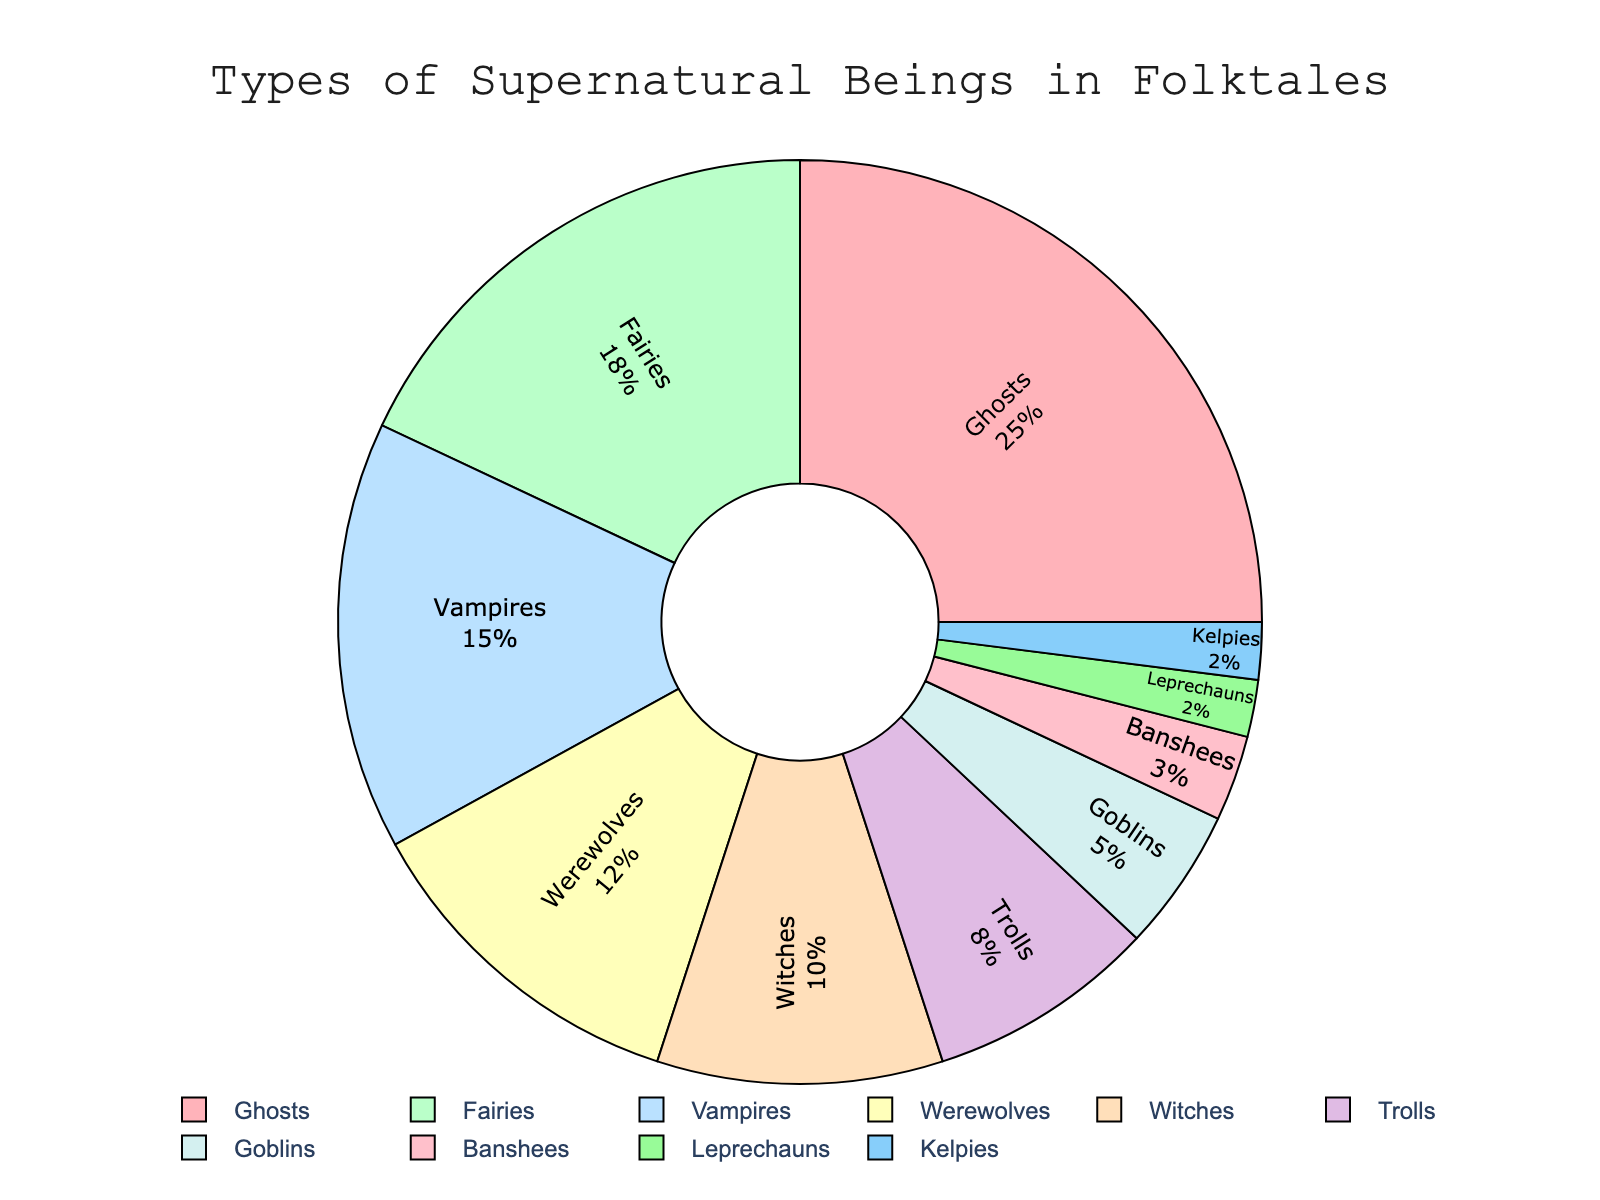What's the total percentage of Ghosts, Fairies, and Vampires? Sum up the percentages of Ghosts (25%), Fairies (18%), and Vampires (15%). The total is 25 + 18 + 15 = 58%.
Answer: 58% Which supernatural being has the lowest percentage in folktales? Identify the being with the smallest percentage. Leprechauns and Kelpies both have 2%, the smallest percentage.
Answer: Leprechauns and Kelpies How many supernatural beings contribute less than 10% each to the total percentage? Count the beings with percentages less than 10%. Werewolves (12%) and higher are excluded. This leaves Witches (10%), Trolls (8%), Goblins (5%), Banshees (3%), Leprechauns (2%), and Kelpies (2%). There are 6.
Answer: 6 Which supernatural being has a higher percentage, Werewolves or Witches? Compare the percentages of Werewolves and Witches. Werewolves have 12%, while Witches have 10%. Thus, Werewolves have a higher percentage.
Answer: Werewolves What's the combined percentage of Trolls, Goblins, and Banshees? Sum the percentages of Trolls (8%), Goblins (5%), and Banshees (3%). The total is 8 + 5 + 3 = 16%.
Answer: 16% What color represents Vampires in the chart? Identify the color assigned to Vampires by looking at the chart. Vampires are marked in a light blue color.
Answer: Light blue If the sum of the percentages of all supernatural beings is 100%, what percentage do Ghosts and Banshees contribute combined? Sum the percentages of Ghosts (25%) and Banshees (3%). The combined total is 25 + 3 = 28%.
Answer: 28% Are there more supernatural beings with a percentage of 5% or less, or those with a percentage greater than 10%? Count the beings with 5% or less and those with greater than 10%. 5% or less: Goblins (5%), Banshees (3%), Leprechauns (2%), Kelpies (2%). That's 4 beings. Greater than 10%: Ghosts (25%), Fairies (18%), Vampires (15%), Werewolves (12%). That's also 4 beings.
Answer: Equal Which entity among Fairies, Witches, and Trolls occupies the largest segment in the pie chart? Compare the percentages of Fairies (18%), Witches (10%), and Trolls (8%). The largest percentage belongs to Fairies.
Answer: Fairies What's the percentage difference between Ghosts and Werewolves? Subtract the percentage of Werewolves (12%) from Ghosts (25%). The difference is 25 - 12 = 13%.
Answer: 13% 